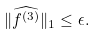Convert formula to latex. <formula><loc_0><loc_0><loc_500><loc_500>\| \widehat { f ^ { ( 3 ) } } \| _ { 1 } \leq \epsilon .</formula> 